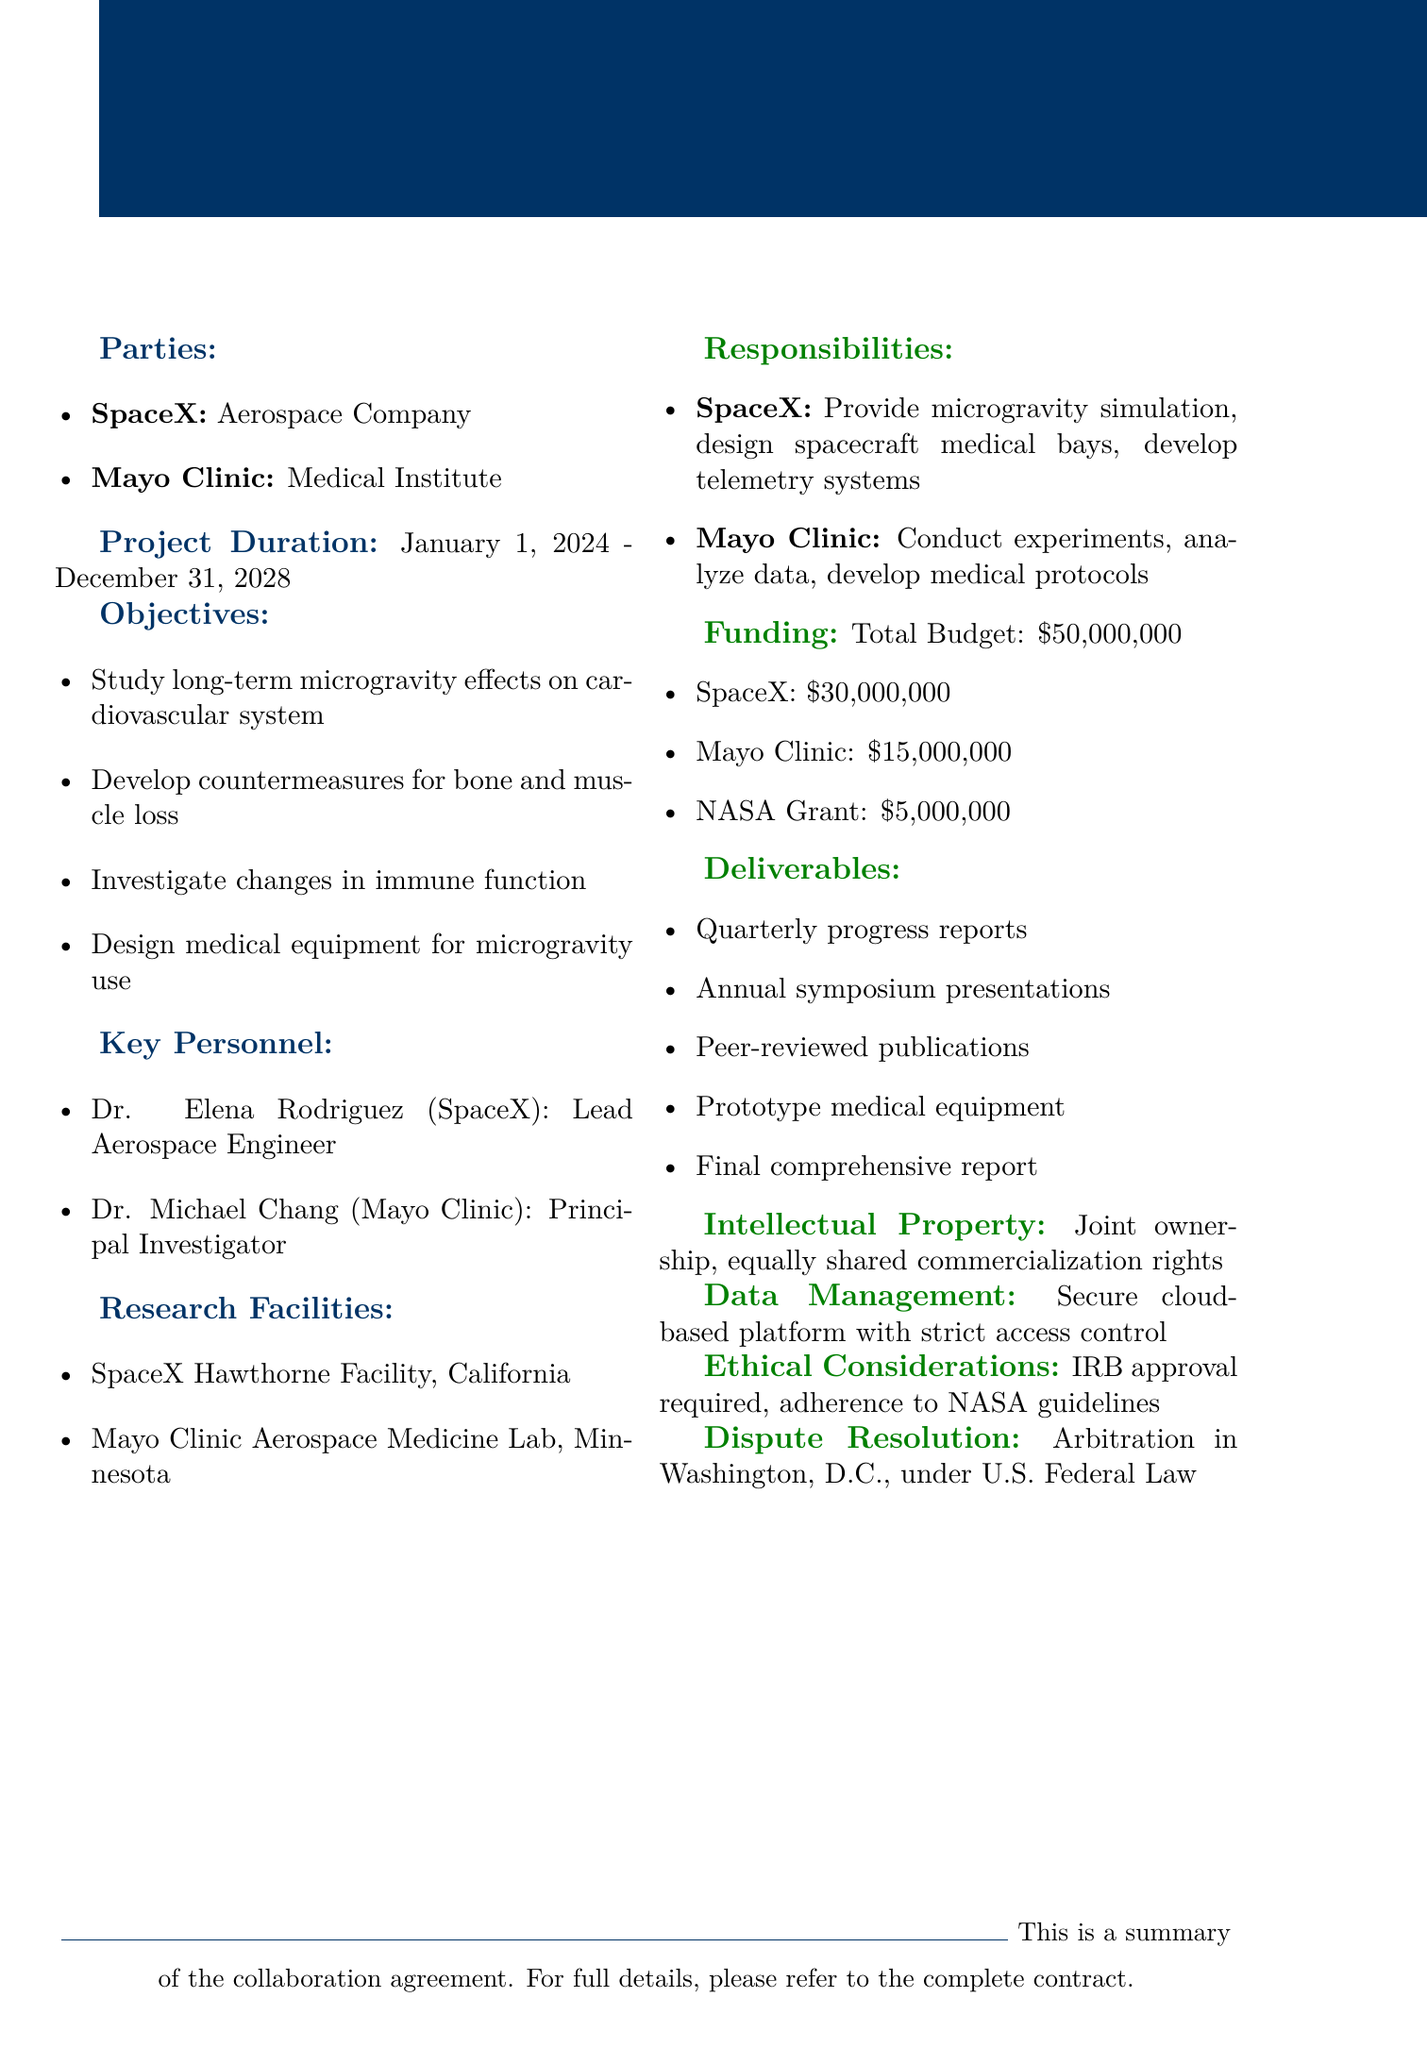What is the project title? The project title is explicitly stated in the document as "Microgravity Physiology Research Collaboration."
Answer: Microgravity Physiology Research Collaboration Who is the representative of SpaceX? The document specifies Gwynne Shotwell as the representative of SpaceX.
Answer: Gwynne Shotwell What is the total budget for the project? The total budget is explicitly mentioned in the document as $50,000,000.
Answer: $50,000,000 When does the project start? The document states that the project begins on January 1, 2024.
Answer: January 1, 2024 What are the primary responsibilities of Mayo Clinic? The responsibilities of Mayo Clinic include conducting physiological experiments, analyzing data, developing medical protocols, and providing medical expertise.
Answer: Conduct physiological experiments in simulated microgravity What type of dispute resolution is specified? The document mentions that arbitration is the method of dispute resolution.
Answer: Arbitration Which facilities will be used by SpaceX? The document lists the SpaceX Hawthorne Facility as one of the research facilities.
Answer: SpaceX Hawthorne Facility How long is the project duration? The project duration spans from January 1, 2024, to December 31, 2028.
Answer: January 1, 2024 - December 31, 2028 Is there joint ownership of intellectual property? The document states there is joint ownership of intellectual property.
Answer: Yes 